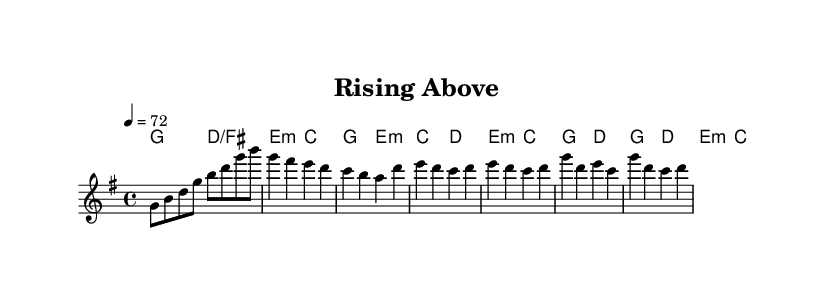What is the key signature of this music? The key signature is G major, which has one sharp (F#). This is determined by looking at the key signature at the beginning of the score.
Answer: G major What is the time signature for this piece? The time signature is 4/4, which is indicated at the beginning of the score. This means there are four beats in each measure, and the quarter note gets one beat.
Answer: 4/4 What is the tempo marking of the piece? The tempo marking is 72 beats per minute, indicated at the beginning of the score by the tempo directive. This tells the performer the speed at which to play the music.
Answer: 72 How many measures are there in the introductory section? The introductory section consists of 4 measures. This can be counted by reviewing the notation in the score and observing the number of groupings that are separated by bar lines.
Answer: 4 What is the first chord in the harmonies? The first chord in the harmonies is G major, which can be identified as it is written at the start of the chord progression within the score.
Answer: G major Which method is primarily used to convey emotion in K-Pop ballads like this one? In K-Pop ballads, emotional expression is primarily conveyed through dynamic contrast and melody. The sheet music displays dynamic markings and melodic phrases that evoke feelings of resilience and strength, characteristic of the genre.
Answer: Dynamic contrast and melody 